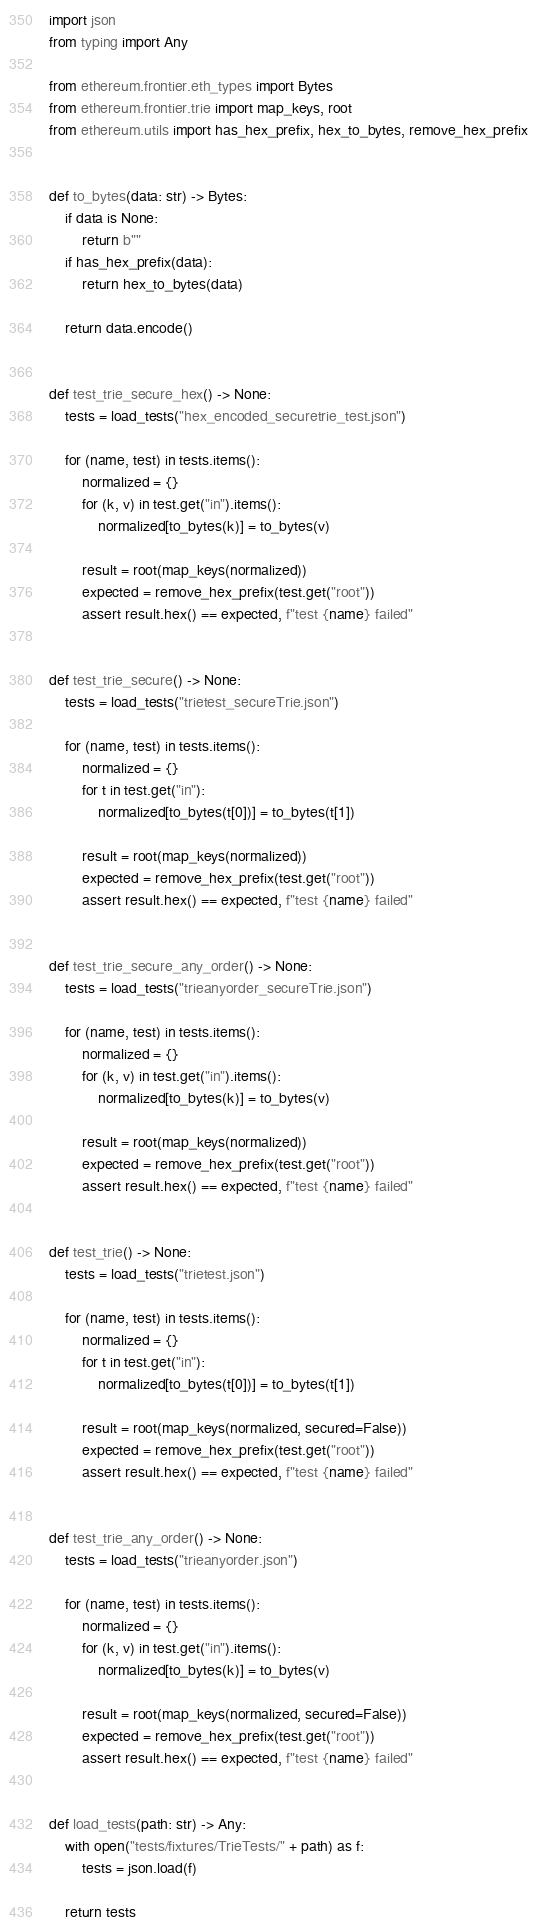<code> <loc_0><loc_0><loc_500><loc_500><_Python_>import json
from typing import Any

from ethereum.frontier.eth_types import Bytes
from ethereum.frontier.trie import map_keys, root
from ethereum.utils import has_hex_prefix, hex_to_bytes, remove_hex_prefix


def to_bytes(data: str) -> Bytes:
    if data is None:
        return b""
    if has_hex_prefix(data):
        return hex_to_bytes(data)

    return data.encode()


def test_trie_secure_hex() -> None:
    tests = load_tests("hex_encoded_securetrie_test.json")

    for (name, test) in tests.items():
        normalized = {}
        for (k, v) in test.get("in").items():
            normalized[to_bytes(k)] = to_bytes(v)

        result = root(map_keys(normalized))
        expected = remove_hex_prefix(test.get("root"))
        assert result.hex() == expected, f"test {name} failed"


def test_trie_secure() -> None:
    tests = load_tests("trietest_secureTrie.json")

    for (name, test) in tests.items():
        normalized = {}
        for t in test.get("in"):
            normalized[to_bytes(t[0])] = to_bytes(t[1])

        result = root(map_keys(normalized))
        expected = remove_hex_prefix(test.get("root"))
        assert result.hex() == expected, f"test {name} failed"


def test_trie_secure_any_order() -> None:
    tests = load_tests("trieanyorder_secureTrie.json")

    for (name, test) in tests.items():
        normalized = {}
        for (k, v) in test.get("in").items():
            normalized[to_bytes(k)] = to_bytes(v)

        result = root(map_keys(normalized))
        expected = remove_hex_prefix(test.get("root"))
        assert result.hex() == expected, f"test {name} failed"


def test_trie() -> None:
    tests = load_tests("trietest.json")

    for (name, test) in tests.items():
        normalized = {}
        for t in test.get("in"):
            normalized[to_bytes(t[0])] = to_bytes(t[1])

        result = root(map_keys(normalized, secured=False))
        expected = remove_hex_prefix(test.get("root"))
        assert result.hex() == expected, f"test {name} failed"


def test_trie_any_order() -> None:
    tests = load_tests("trieanyorder.json")

    for (name, test) in tests.items():
        normalized = {}
        for (k, v) in test.get("in").items():
            normalized[to_bytes(k)] = to_bytes(v)

        result = root(map_keys(normalized, secured=False))
        expected = remove_hex_prefix(test.get("root"))
        assert result.hex() == expected, f"test {name} failed"


def load_tests(path: str) -> Any:
    with open("tests/fixtures/TrieTests/" + path) as f:
        tests = json.load(f)

    return tests
</code> 